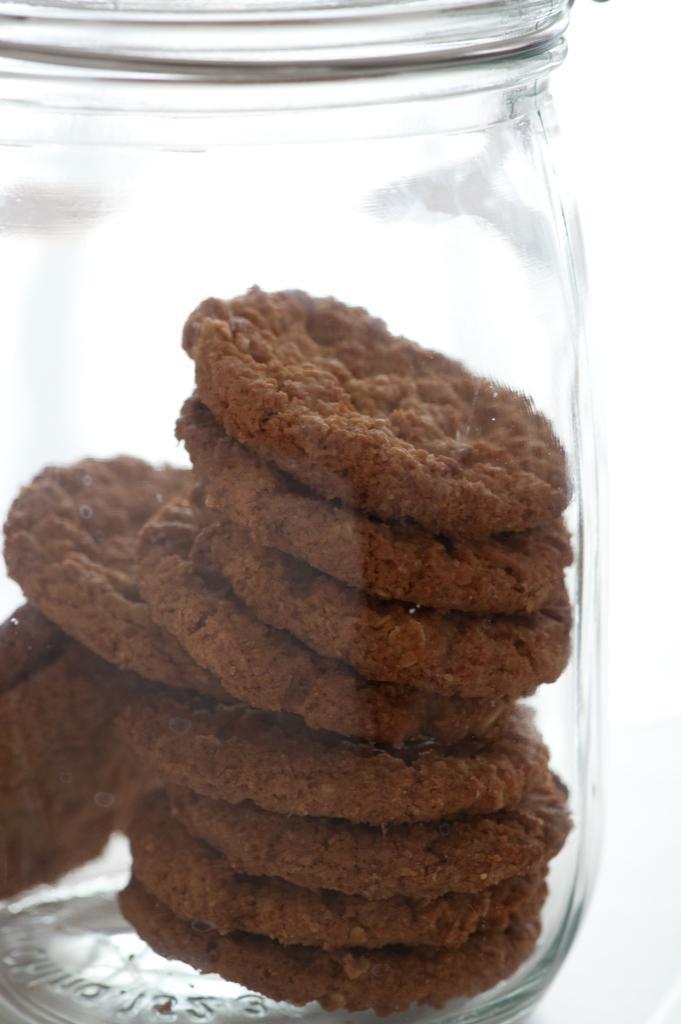In one or two sentences, can you explain what this image depicts? In this glass jar we can see brown cookies or biscuit. 